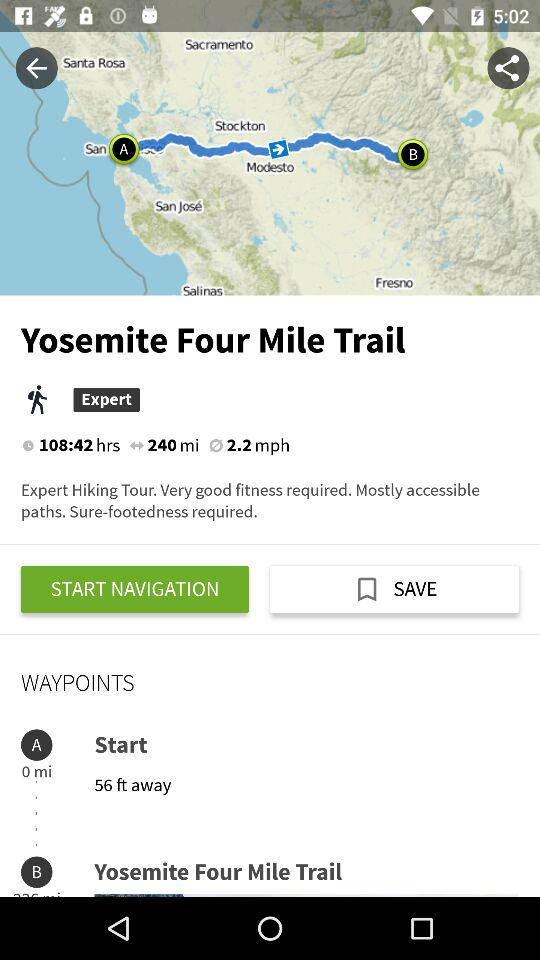What is the whole trek's distance? The whole trek's distance is 240 miles. 